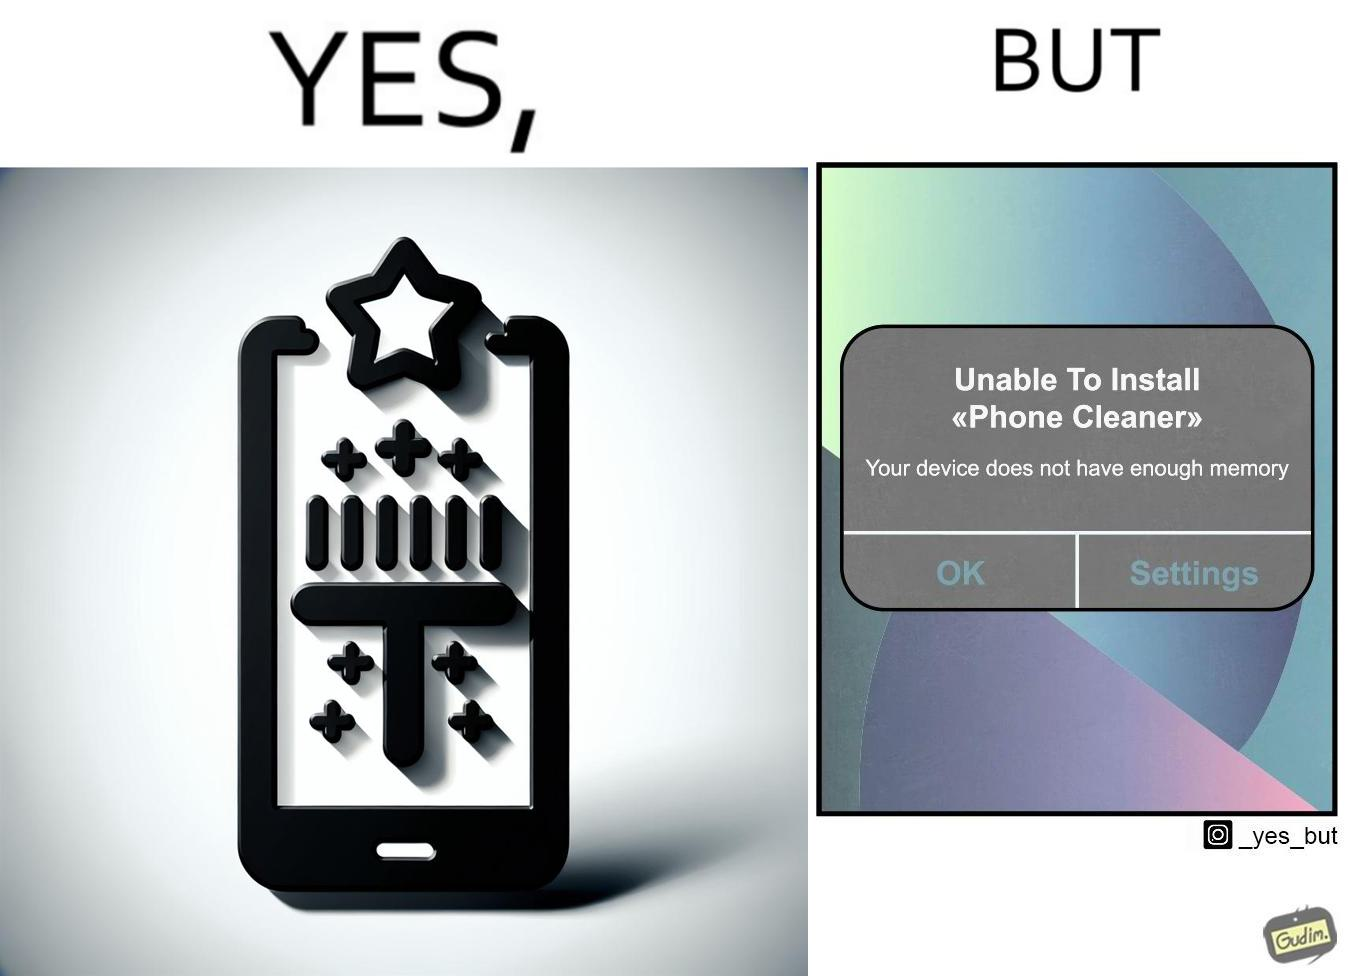Is this a satirical image? Yes, this image is satirical. 